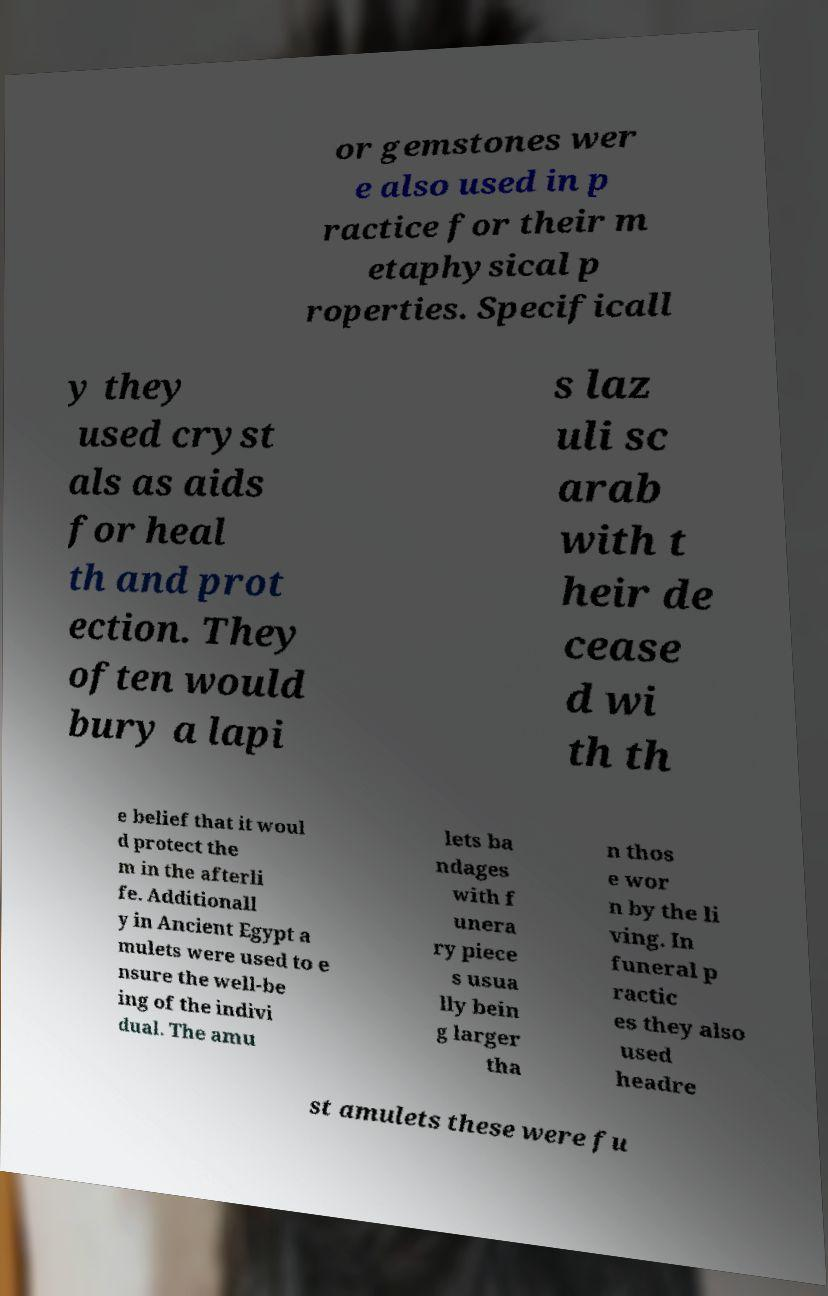Can you accurately transcribe the text from the provided image for me? or gemstones wer e also used in p ractice for their m etaphysical p roperties. Specificall y they used cryst als as aids for heal th and prot ection. They often would bury a lapi s laz uli sc arab with t heir de cease d wi th th e belief that it woul d protect the m in the afterli fe. Additionall y in Ancient Egypt a mulets were used to e nsure the well-be ing of the indivi dual. The amu lets ba ndages with f unera ry piece s usua lly bein g larger tha n thos e wor n by the li ving. In funeral p ractic es they also used headre st amulets these were fu 